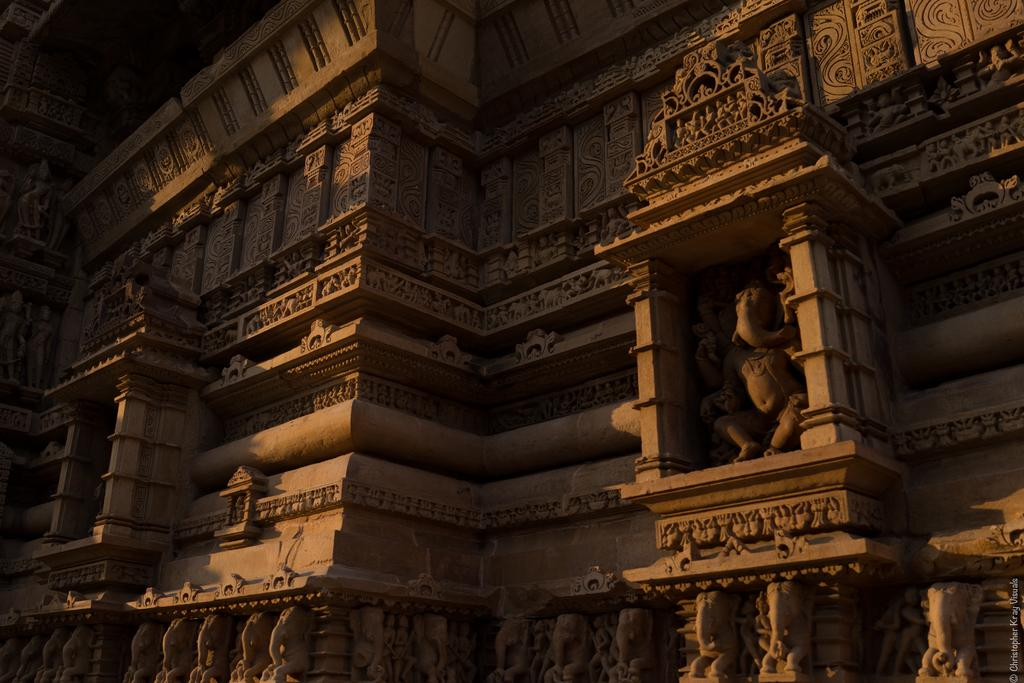What type of architecture is shown in the image? The image depicts ancient architecture. Are there any decorative elements on the walls in the image? Yes, there are sculptures on the wall in the image. What color are the crayons used to draw the trucks in the image? There are no crayons or trucks present in the image; it features ancient architecture and sculptures on the wall. 